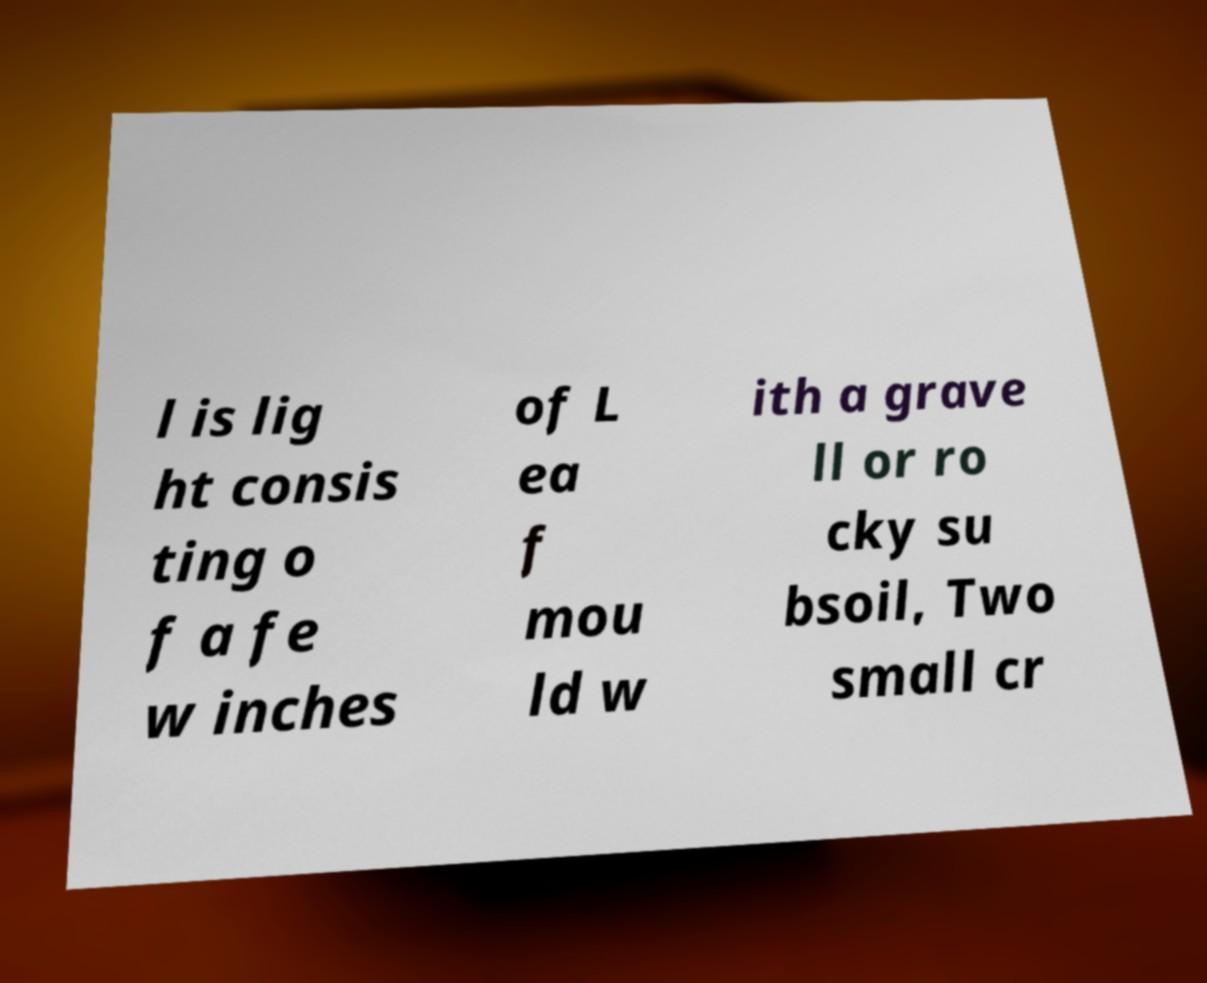Could you assist in decoding the text presented in this image and type it out clearly? l is lig ht consis ting o f a fe w inches of L ea f mou ld w ith a grave ll or ro cky su bsoil, Two small cr 